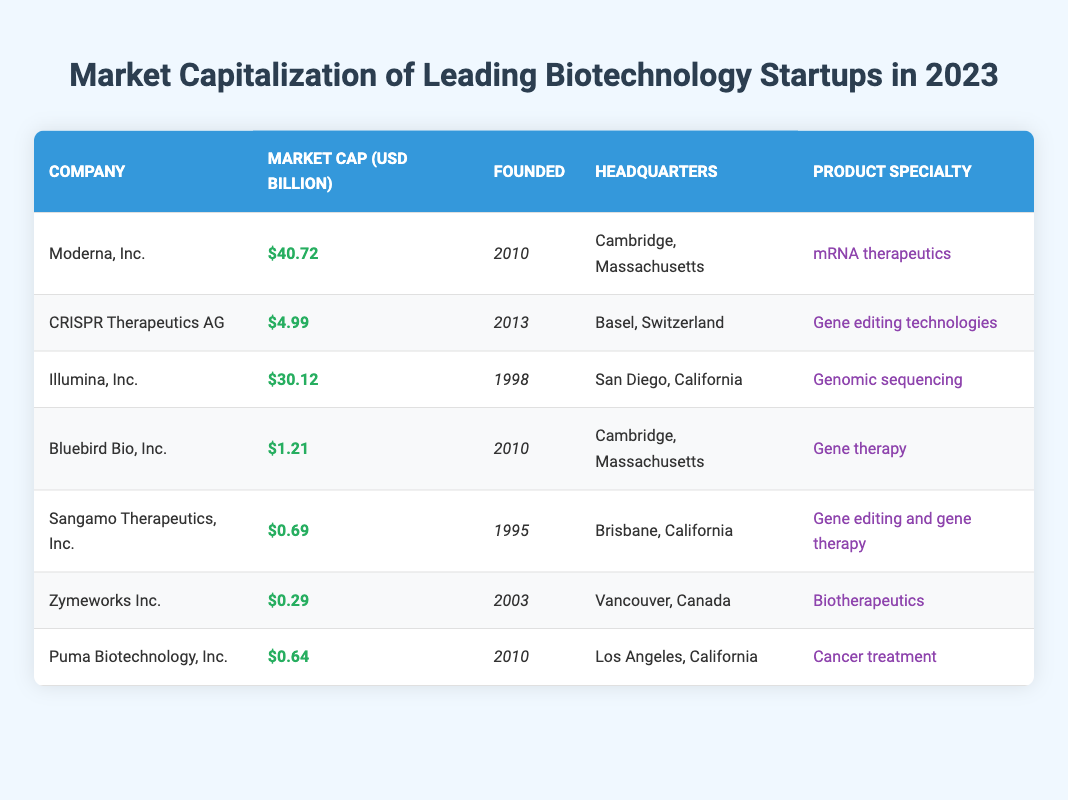What is the market capitalization of Moderna, Inc.? The table lists Moderna, Inc. under the "Company" column, and its corresponding market capitalization value in the "Market Cap (USD Billion)" column is 40.72.
Answer: 40.72 Which company has the highest market capitalization in 2023? By reviewing the "Market Cap (USD Billion)" column, I see that Moderna, Inc. has the highest value at 40.72; thus, it is the leading company in terms of market capitalization.
Answer: Moderna, Inc How many companies have a market capitalization greater than 5 billion USD? By examining the "Market Cap (USD Billion)" column, Moderna and Illumina are the only companies with values greater than 5 billion USD, indicating that there are a total of 2 such companies.
Answer: 2 What is the average market capitalization of the companies listed? To calculate the average, I first sum the market capitalizations: (40.72 + 4.99 + 30.12 + 1.21 + 0.69 + 0.29 + 0.64) = 78.76. Since there are 7 companies, the average is 78.76 / 7 = 11.25.
Answer: 11.25 Was Zymeworks Inc. founded before 2010? The founded year for Zymeworks Inc. is 2003, and since 2003 is before 2010, the statement is true.
Answer: Yes Which product specialty has the lowest market capitalization? By comparing all companies in the "Market Cap (USD Billion)" column, Zymeworks Inc., with a market cap of 0.29 and specializing in biotherapeutics, has the lowest value.
Answer: Biotherapeutics Which company has the same headquarters as Bluebird Bio, Inc.? I check the headquarters of Bluebird Bio, Inc. (Cambridge, Massachusetts) and find that Moderna, Inc. also shares the same headquarters location.
Answer: Moderna, Inc What is the difference in market capitalization between CRISPR Therapeutics and Sangamo Therapeutics? By observing the market capitalizations, CRISPR has 4.99 and Sangamo has 0.69. The difference is calculated as 4.99 - 0.69 = 4.30.
Answer: 4.30 